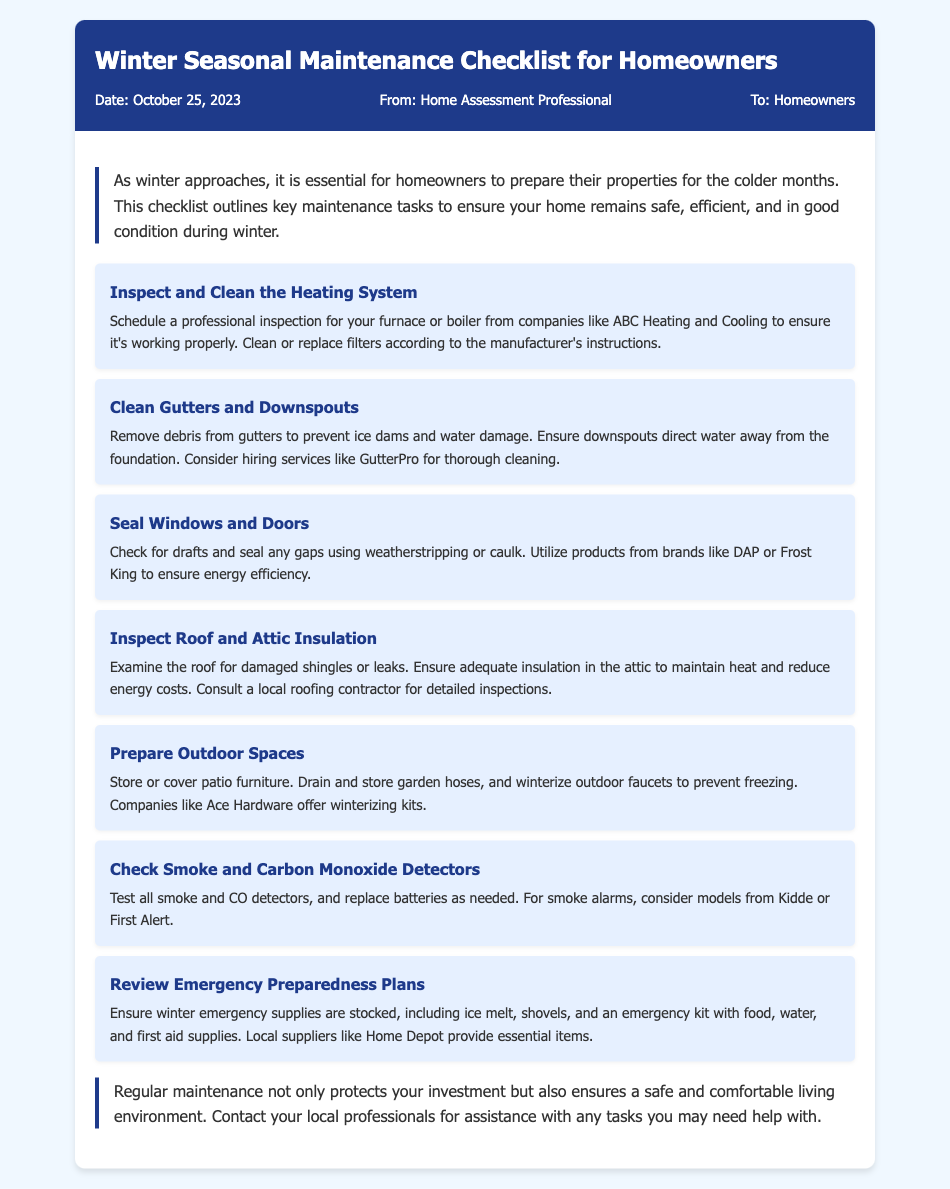What is the title of the memo? The title of the memo is clearly stated at the beginning of the document, and it is "Winter Seasonal Maintenance Checklist for Homeowners."
Answer: Winter Seasonal Maintenance Checklist for Homeowners When was the memo dated? The date mentioned in the document provides the specific date when the memo was created, which is October 25, 2023.
Answer: October 25, 2023 Who is the memo from? The sender of the memo is indicated in the document as "Home Assessment Professional."
Answer: Home Assessment Professional What is the first task in the winter checklist? The tasks are organized in a list, with the first task being "Inspect and Clean the Heating System."
Answer: Inspect and Clean the Heating System Which company is recommended for gutter cleaning? The document suggests using services from "GutterPro" for thorough cleaning of gutters and downspouts.
Answer: GutterPro What should homeowners test for regarding safety detectors? The memo specifies that homeowners should test all smoke and carbon monoxide detectors.
Answer: Smoke and carbon monoxide detectors What type of maintenance does the checklist promote overall? The memo emphasizes "regular maintenance" for property upkeep during the winter months.
Answer: Regular maintenance What does the memo suggest homeowners do with patio furniture? The maintenance checklist advises homeowners to "store or cover patio furniture."
Answer: Store or cover patio furniture 